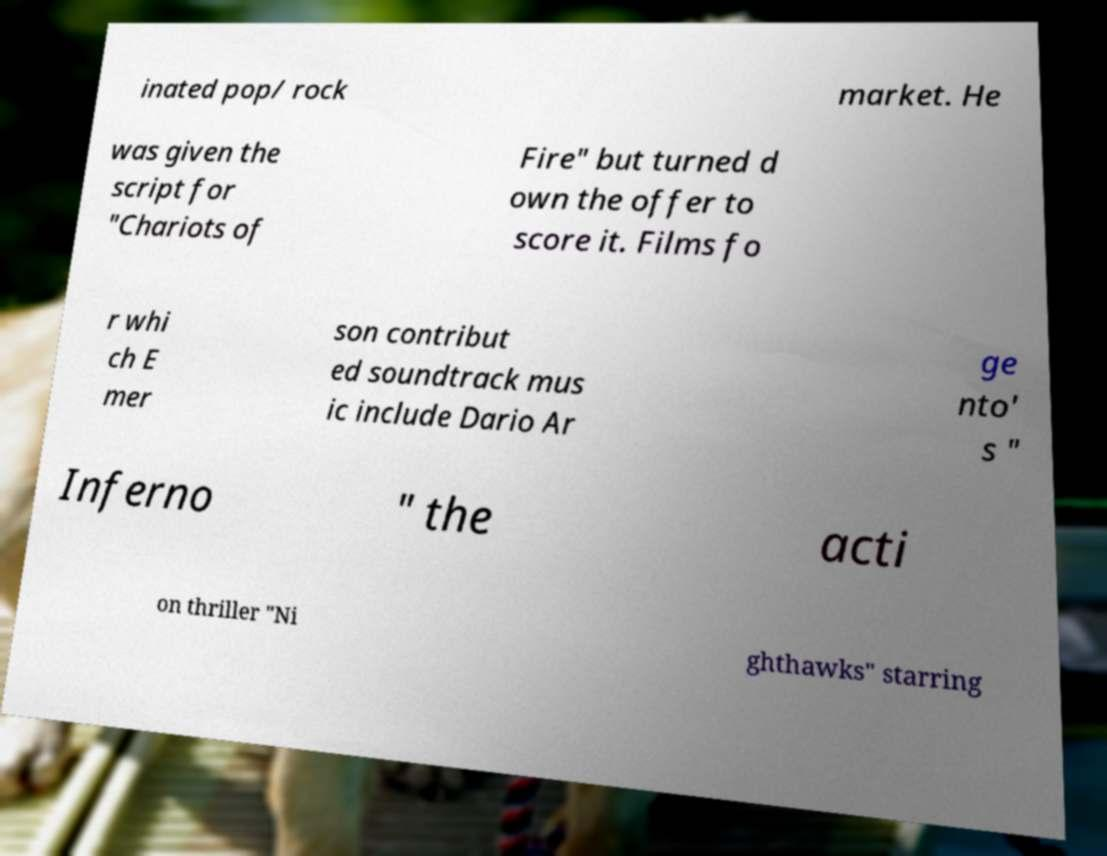Can you accurately transcribe the text from the provided image for me? inated pop/ rock market. He was given the script for "Chariots of Fire" but turned d own the offer to score it. Films fo r whi ch E mer son contribut ed soundtrack mus ic include Dario Ar ge nto' s " Inferno " the acti on thriller "Ni ghthawks" starring 